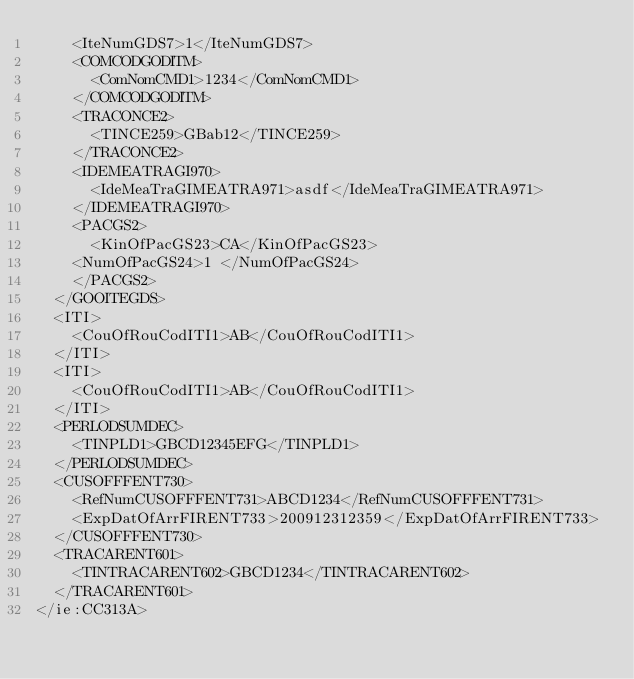<code> <loc_0><loc_0><loc_500><loc_500><_XML_>    <IteNumGDS7>1</IteNumGDS7>
    <COMCODGODITM>
      <ComNomCMD1>1234</ComNomCMD1>
    </COMCODGODITM>
    <TRACONCE2>
      <TINCE259>GBab12</TINCE259>
    </TRACONCE2>
    <IDEMEATRAGI970>
      <IdeMeaTraGIMEATRA971>asdf</IdeMeaTraGIMEATRA971>
    </IDEMEATRAGI970>
    <PACGS2>
      <KinOfPacGS23>CA</KinOfPacGS23>
    <NumOfPacGS24>1 </NumOfPacGS24>
    </PACGS2>
  </GOOITEGDS>
  <ITI>
    <CouOfRouCodITI1>AB</CouOfRouCodITI1>
  </ITI>
  <ITI>
    <CouOfRouCodITI1>AB</CouOfRouCodITI1>
  </ITI>
  <PERLODSUMDEC>
    <TINPLD1>GBCD12345EFG</TINPLD1>
  </PERLODSUMDEC>
  <CUSOFFFENT730>
    <RefNumCUSOFFFENT731>ABCD1234</RefNumCUSOFFFENT731>
    <ExpDatOfArrFIRENT733>200912312359</ExpDatOfArrFIRENT733>
  </CUSOFFFENT730>
  <TRACARENT601>
    <TINTRACARENT602>GBCD1234</TINTRACARENT602>
  </TRACARENT601>
</ie:CC313A>

</code> 